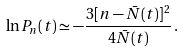<formula> <loc_0><loc_0><loc_500><loc_500>\ln P _ { n } ( t ) \simeq - \frac { 3 [ n - \bar { N } ( t ) ] ^ { 2 } } { 4 \bar { N } ( t ) } \, .</formula> 